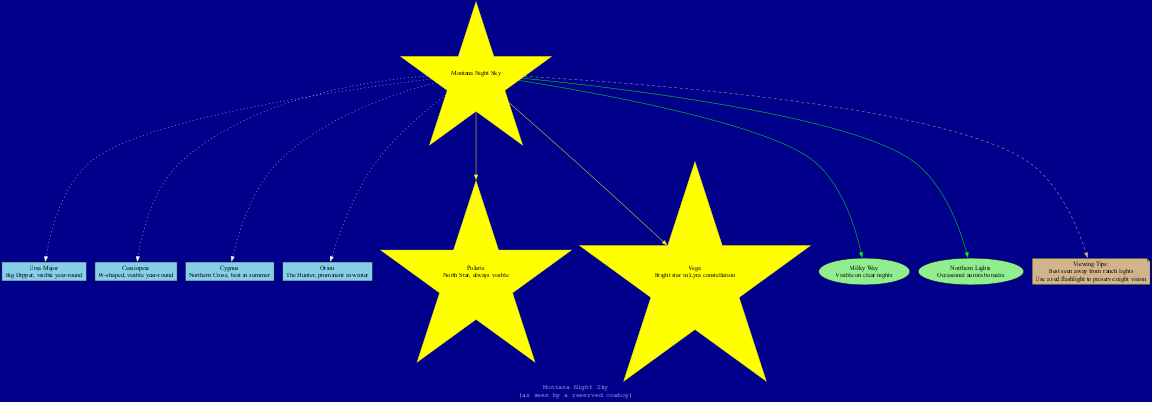What constellations are visible year-round from Montana? The diagram lists two constellations specifically described as being visible year-round: Ursa Major and Cassiopeia.
Answer: Ursa Major, Cassiopeia How many stars are featured in the diagram? The diagram has a total of two specific stars listed: Polaris and Vega.
Answer: 2 Which constellation is described as the "Hunter"? The diagram includes Orion, which is explicitly noted as "The Hunter" in its description.
Answer: Orion What color is the node representing the Milky Way? The diagram shows the Milky Way feature node filled in light green, as indicated in the features section.
Answer: Light green Which viewing tip suggests using a specific type of flashlight? The diagram mentions using a red flashlight to preserve night vision, specifically noted as a viewing tip.
Answer: Red flashlight Which constellation is best seen in summer? The diagram indicates that Cygnus is best seen in summer, according to its description.
Answer: Cygnus How are the edges connecting the constellations styled? The edges connecting the constellations to the center node are styled as dotted lines, as specified in the edge definitions in the diagram.
Answer: Dotted What feature is described as the "North Star"? The diagram clearly identifies Polaris as the North Star, providing its description in the star section.
Answer: Polaris What is one way to enhance stargazing according to the tips? One of the viewing tips emphasizes that stargazing is best away from ranch lights, as indicated in the viewing tips section of the diagram.
Answer: Away from ranch lights 